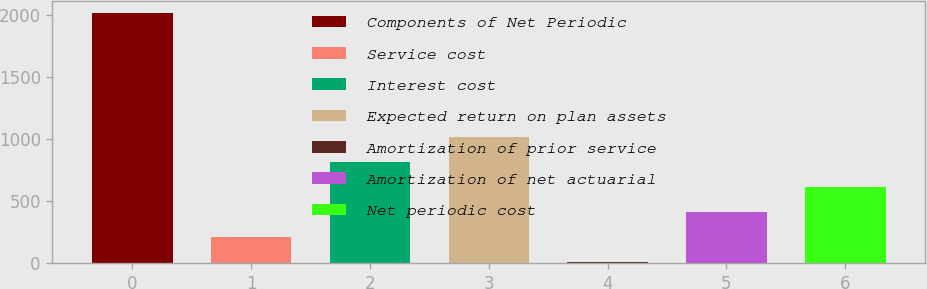Convert chart to OTSL. <chart><loc_0><loc_0><loc_500><loc_500><bar_chart><fcel>Components of Net Periodic<fcel>Service cost<fcel>Interest cost<fcel>Expected return on plan assets<fcel>Amortization of prior service<fcel>Amortization of net actuarial<fcel>Net periodic cost<nl><fcel>2010<fcel>212.7<fcel>811.8<fcel>1011.5<fcel>13<fcel>412.4<fcel>612.1<nl></chart> 